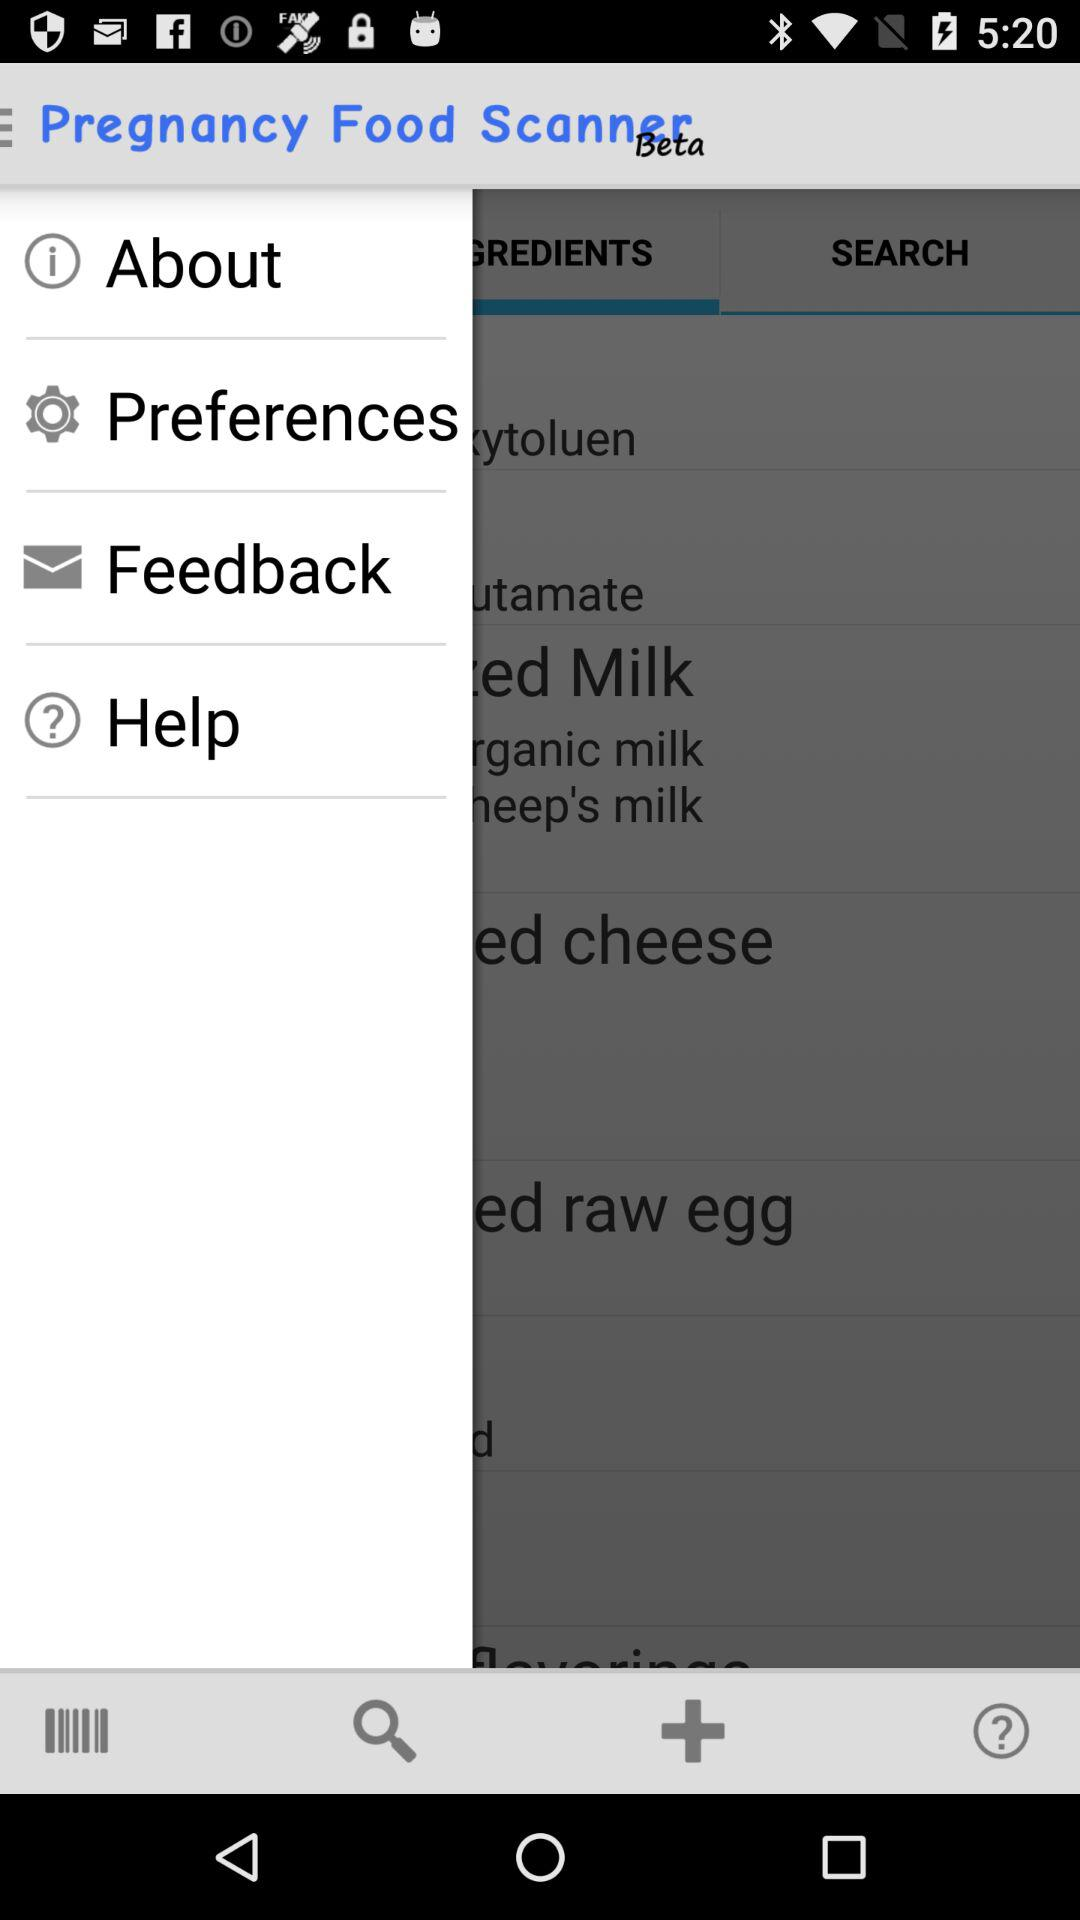What is the application name? The application name is "Pregnancy Food Scanner Beta". 